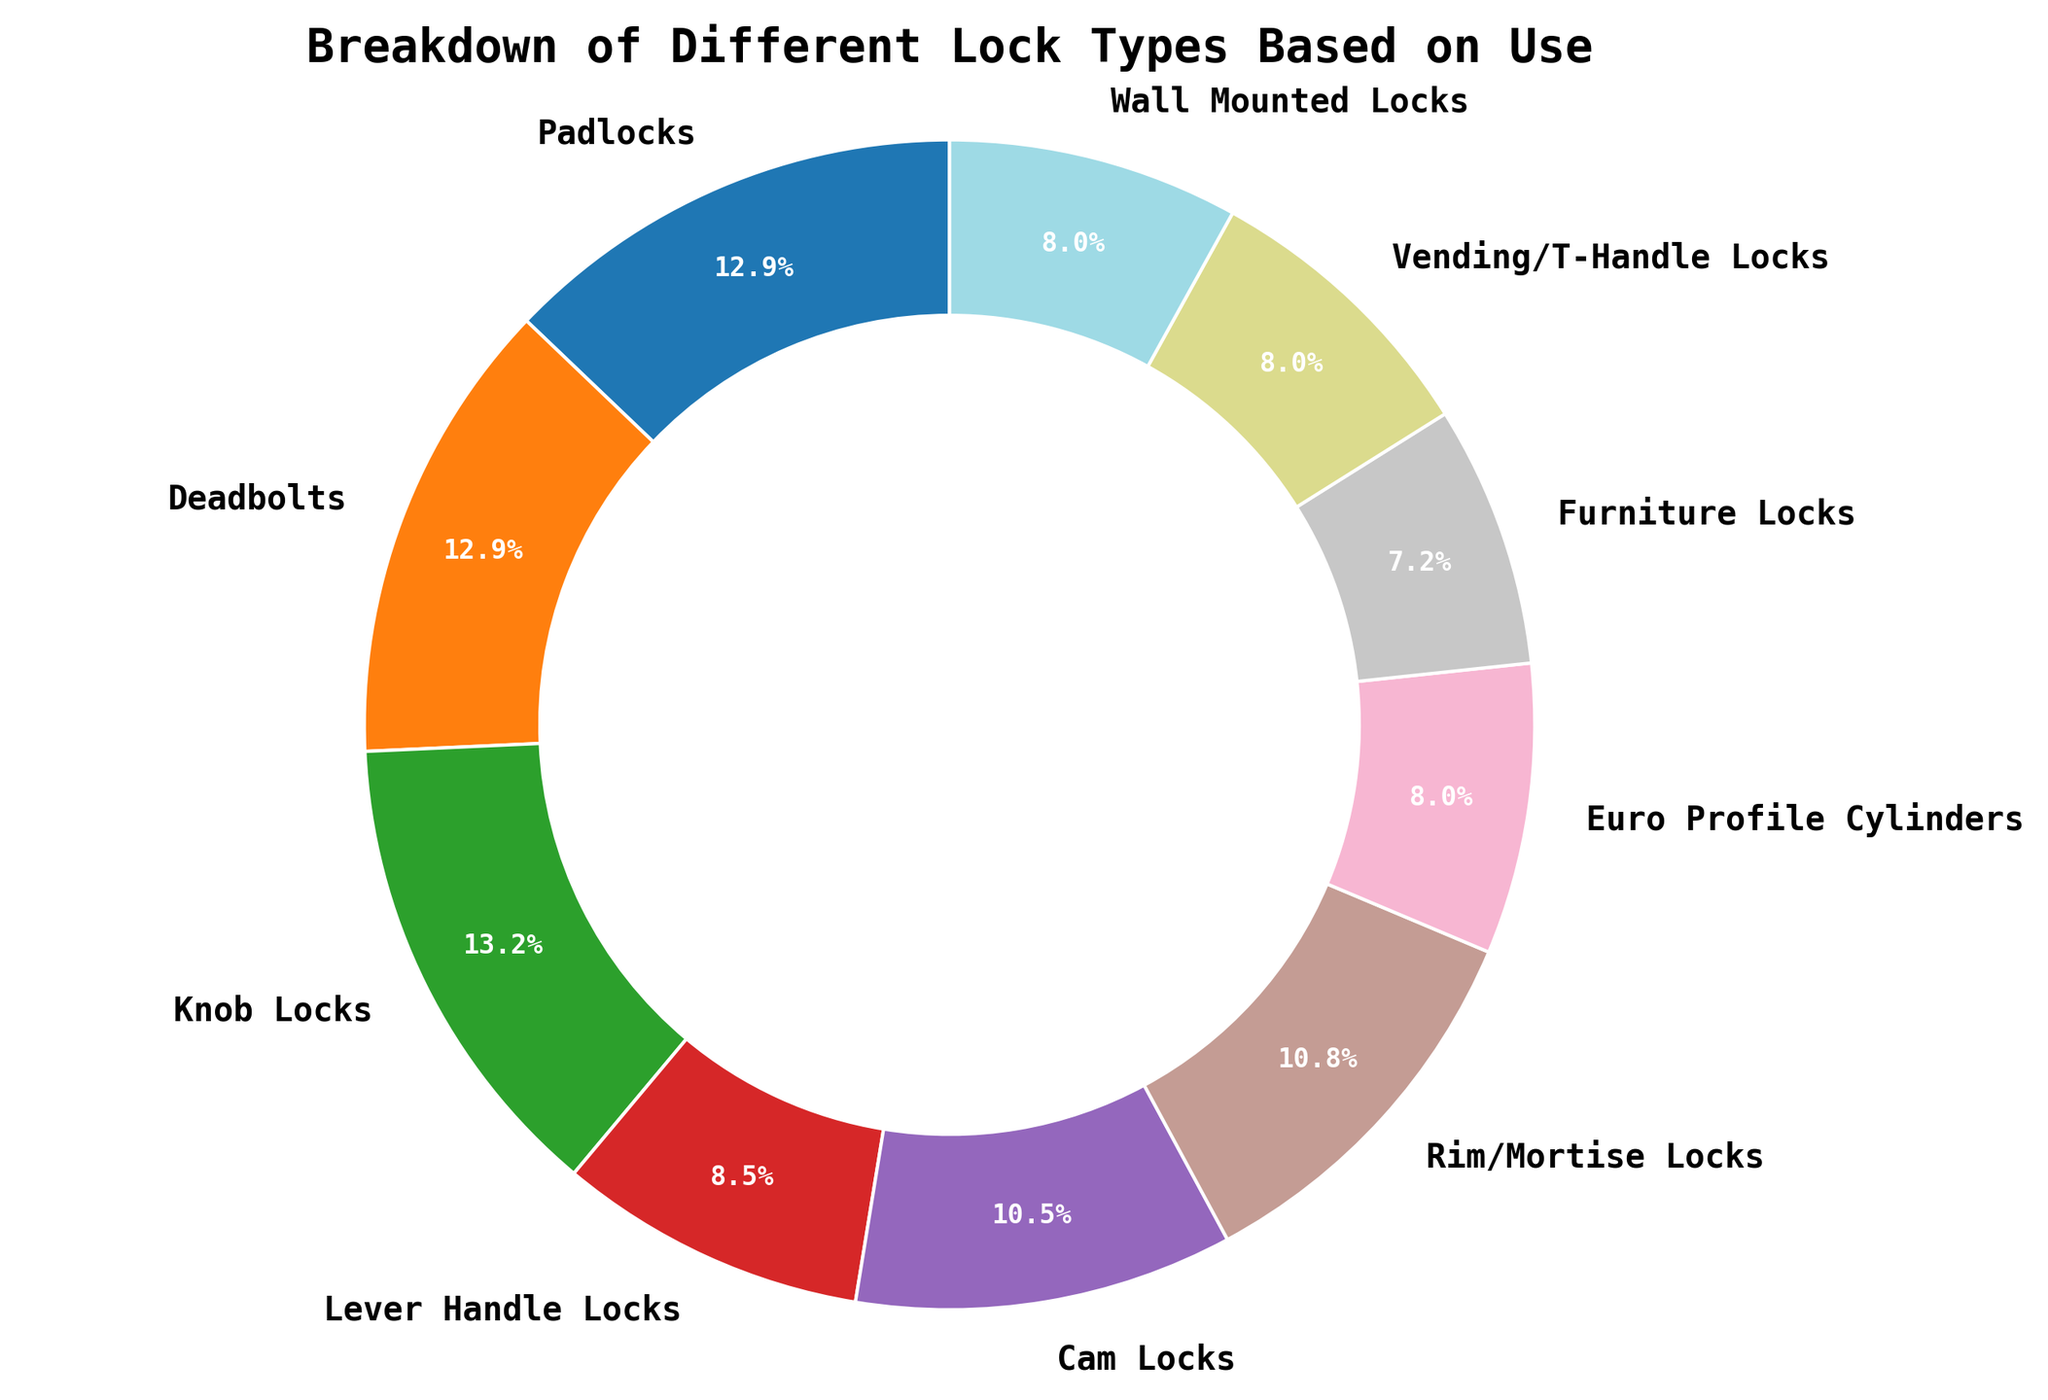Which lock type has the highest total usage across all categories? The lock type with the highest total usage can be identified by adding up the usage values across all categories for each lock type. Knob Locks have the highest total usage percentage when visually inspecting the ring chart.
Answer: Knob Locks Which lock type has the lowest usage in the 'Residential' category? By examining the sectors of the ring chart corresponding to residential usage, Vending/T-Handle Locks and Wall Mounted Locks both have the smallest visible sections.
Answer: Vending/T-Handle Locks, Wall Mounted Locks Compare the usage of Deadbolts and Lever Handle Locks in the 'Commercial' category. Which one has more usage and by how much? Deadbolts and Lever Handle Locks both have sectors representing their usage in the 'Commercial' category. Deadbolts have a smaller sector compared to Lever Handle Locks, indicating lower usage. Lever Handle Locks have more usage by the difference in their two sectors. Deadbolts have 35 uses, and Lever Handle Locks have 40 uses.
Answer: Lever Handle Locks by 5 What is the combined total usage percentage of Rim/Mortise Locks and Euro Profile Cylinders? Adding the percentages represented by the sectors for Rim/Mortise Locks and Euro Profile Cylinders gives the combined total. Calculate the sum of their individual percentages in the chart.
Answer: 60.3% Which lock type has an equal distribution of usage across at least two categories? By inspecting the pie chart segments for each lock type, Rim/Mortise Locks have equal 50% usage in the Residential and Commercial categories and smaller portions in Automotive and Other categories.
Answer: Rim/Mortise Locks Which category has the least representation in terms of usage? Comparing the sectors for each category in the pie chart, the smallest portions visually represent 'Other' usage for most lock types.
Answer: Other What's the difference in total usage percentage between Padlocks and Cam Locks? Subtract the total percentage of Cam Locks usage from the total percentage of Padlocks usage by looking at corresponding sectors of the ring.
Answer: 6.4% 